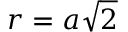Convert formula to latex. <formula><loc_0><loc_0><loc_500><loc_500>r = a \sqrt { 2 }</formula> 